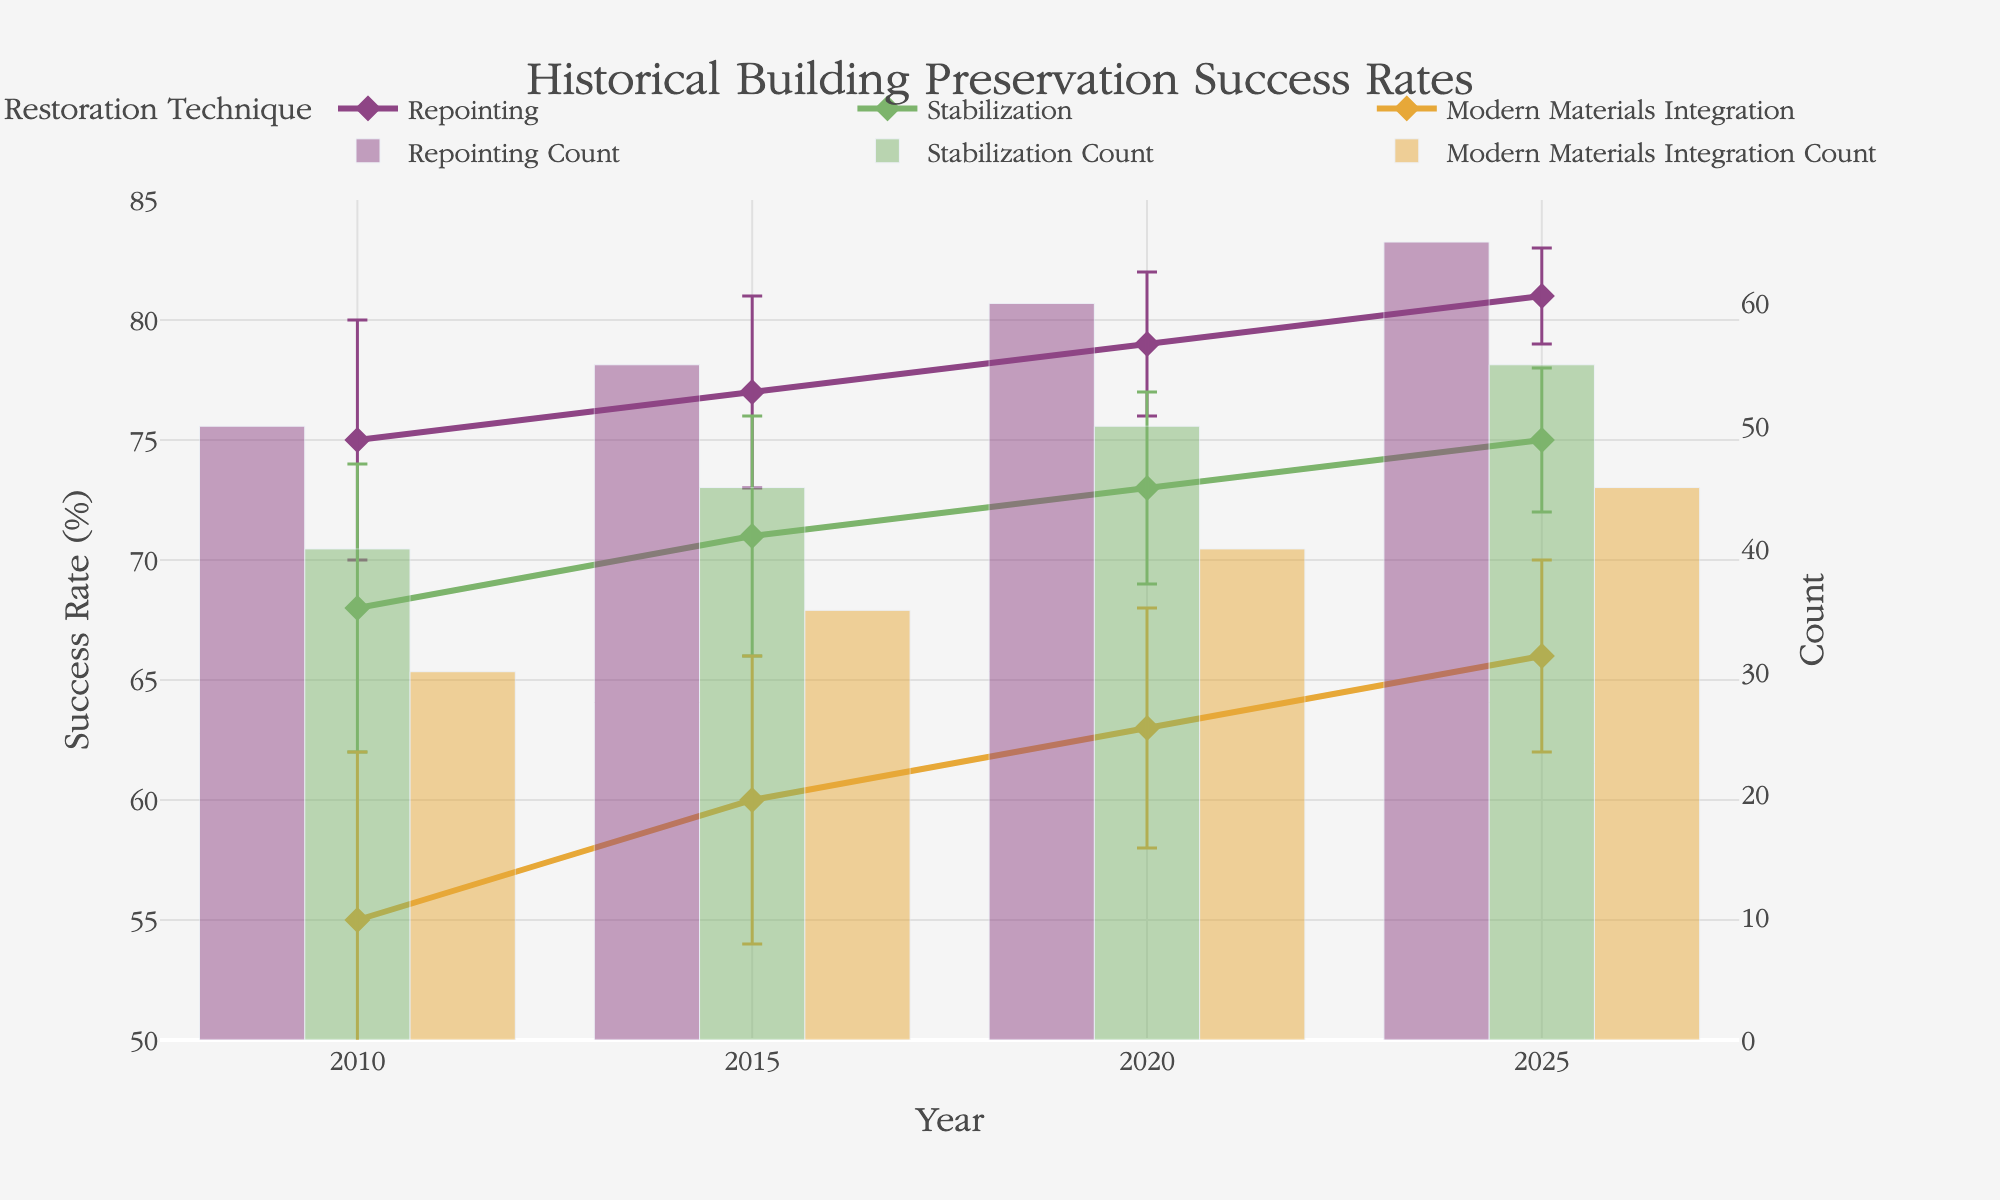What is the title of the figure? The title of the figure is displayed at the top and is labeled "Historical Building Preservation Success Rates".
Answer: Historical Building Preservation Success Rates Which restoration technique had the highest success rate in 2025? Look at the lines corresponding to each restoration technique in the year 2025. The one that reaches the highest value on the y-axis represents the highest success rate.
Answer: Repointing How many counts were there for the Stabilization technique in 2020? Refer to the bar chart component of the figure. The Stabilization technique's count bar in 2020 indicates the number of counts.
Answer: 50 Between 2010 and 2025, which restoration technique showed the greatest increase in success rate? Examine the line plots for each technique from 2010 to 2025. Calculate the change by subtracting the 2010 success rate from the 2025 success rate for each technique, and identify the one with the highest increase.
Answer: Repointing What was the difference in success rate between Stabilization and Modern Materials Integration in 2015? Find the success rates for both techniques in 2015 from their respective line plots or markers. Subtract the success rate of Modern Materials Integration from that of Stabilization.
Answer: 11% Which restoration technique shows the least amount of change in success rate from 2010 to 2025? Determine the change in success rate for each technique from 2010 to 2025 and compare them. The smallest difference indicates the least amount of change.
Answer: Modern Materials Integration How did the success rates for Repointing and Stabilization compare in 2020? Look at the success rates for both techniques in the year 2020 and note their values. Compare them to determine which is higher or if they're equal.
Answer: Repointing is higher In which year did Stabilization achieve its highest success rate? Identify the highest point on the success rate line plot for Stabilization and note the corresponding year on the x-axis.
Answer: 2025 What is the error range for the success rate of Modern Materials Integration in 2020? Find the error bar for Modern Materials Integration in 2020 and determine its range by adding and subtracting the error value from the success rate percentage.
Answer: 58% to 68% Which technique had the most consistent success rate (least error) over the years? Examine the error bars for each technique across all years. The technique with the smallest and most consistent error bars has the most consistent success rate.
Answer: Repointing 